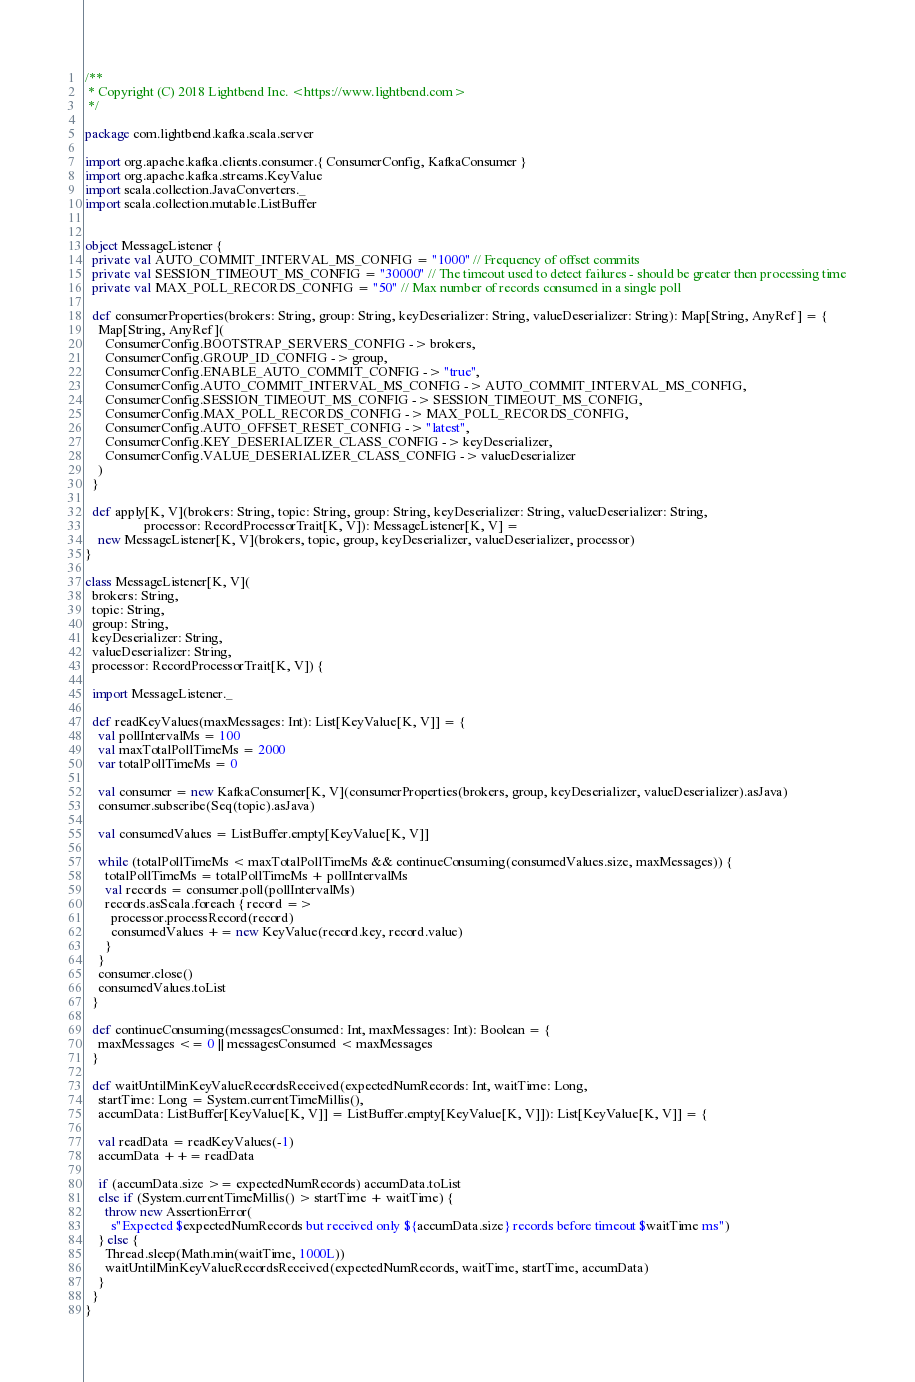Convert code to text. <code><loc_0><loc_0><loc_500><loc_500><_Scala_>/**
 * Copyright (C) 2018 Lightbend Inc. <https://www.lightbend.com>
 */

package com.lightbend.kafka.scala.server

import org.apache.kafka.clients.consumer.{ ConsumerConfig, KafkaConsumer }
import org.apache.kafka.streams.KeyValue
import scala.collection.JavaConverters._
import scala.collection.mutable.ListBuffer


object MessageListener {
  private val AUTO_COMMIT_INTERVAL_MS_CONFIG = "1000" // Frequency of offset commits
  private val SESSION_TIMEOUT_MS_CONFIG = "30000" // The timeout used to detect failures - should be greater then processing time
  private val MAX_POLL_RECORDS_CONFIG = "50" // Max number of records consumed in a single poll

  def consumerProperties(brokers: String, group: String, keyDeserializer: String, valueDeserializer: String): Map[String, AnyRef] = {
    Map[String, AnyRef](
      ConsumerConfig.BOOTSTRAP_SERVERS_CONFIG -> brokers,
      ConsumerConfig.GROUP_ID_CONFIG -> group,
      ConsumerConfig.ENABLE_AUTO_COMMIT_CONFIG -> "true",
      ConsumerConfig.AUTO_COMMIT_INTERVAL_MS_CONFIG -> AUTO_COMMIT_INTERVAL_MS_CONFIG,
      ConsumerConfig.SESSION_TIMEOUT_MS_CONFIG -> SESSION_TIMEOUT_MS_CONFIG,
      ConsumerConfig.MAX_POLL_RECORDS_CONFIG -> MAX_POLL_RECORDS_CONFIG,
      ConsumerConfig.AUTO_OFFSET_RESET_CONFIG -> "latest",
      ConsumerConfig.KEY_DESERIALIZER_CLASS_CONFIG -> keyDeserializer,
      ConsumerConfig.VALUE_DESERIALIZER_CLASS_CONFIG -> valueDeserializer
    )
  }

  def apply[K, V](brokers: String, topic: String, group: String, keyDeserializer: String, valueDeserializer: String,
                  processor: RecordProcessorTrait[K, V]): MessageListener[K, V] =
    new MessageListener[K, V](brokers, topic, group, keyDeserializer, valueDeserializer, processor)
}

class MessageListener[K, V](
  brokers: String,
  topic: String,
  group: String,
  keyDeserializer: String,
  valueDeserializer: String,
  processor: RecordProcessorTrait[K, V]) {

  import MessageListener._

  def readKeyValues(maxMessages: Int): List[KeyValue[K, V]] = {
    val pollIntervalMs = 100
    val maxTotalPollTimeMs = 2000
    var totalPollTimeMs = 0

    val consumer = new KafkaConsumer[K, V](consumerProperties(brokers, group, keyDeserializer, valueDeserializer).asJava)
    consumer.subscribe(Seq(topic).asJava)

    val consumedValues = ListBuffer.empty[KeyValue[K, V]]

    while (totalPollTimeMs < maxTotalPollTimeMs && continueConsuming(consumedValues.size, maxMessages)) {
      totalPollTimeMs = totalPollTimeMs + pollIntervalMs
      val records = consumer.poll(pollIntervalMs)
      records.asScala.foreach { record =>
        processor.processRecord(record)
        consumedValues += new KeyValue(record.key, record.value)
      }
    }
    consumer.close()
    consumedValues.toList
  }

  def continueConsuming(messagesConsumed: Int, maxMessages: Int): Boolean = {
    maxMessages <= 0 || messagesConsumed < maxMessages
  }

  def waitUntilMinKeyValueRecordsReceived(expectedNumRecords: Int, waitTime: Long,
    startTime: Long = System.currentTimeMillis(),
    accumData: ListBuffer[KeyValue[K, V]] = ListBuffer.empty[KeyValue[K, V]]): List[KeyValue[K, V]] = {

    val readData = readKeyValues(-1)
    accumData ++= readData

    if (accumData.size >= expectedNumRecords) accumData.toList
    else if (System.currentTimeMillis() > startTime + waitTime) {
      throw new AssertionError(
        s"Expected $expectedNumRecords but received only ${accumData.size} records before timeout $waitTime ms")
    } else {
      Thread.sleep(Math.min(waitTime, 1000L))
      waitUntilMinKeyValueRecordsReceived(expectedNumRecords, waitTime, startTime, accumData)
    }
  }
}
</code> 